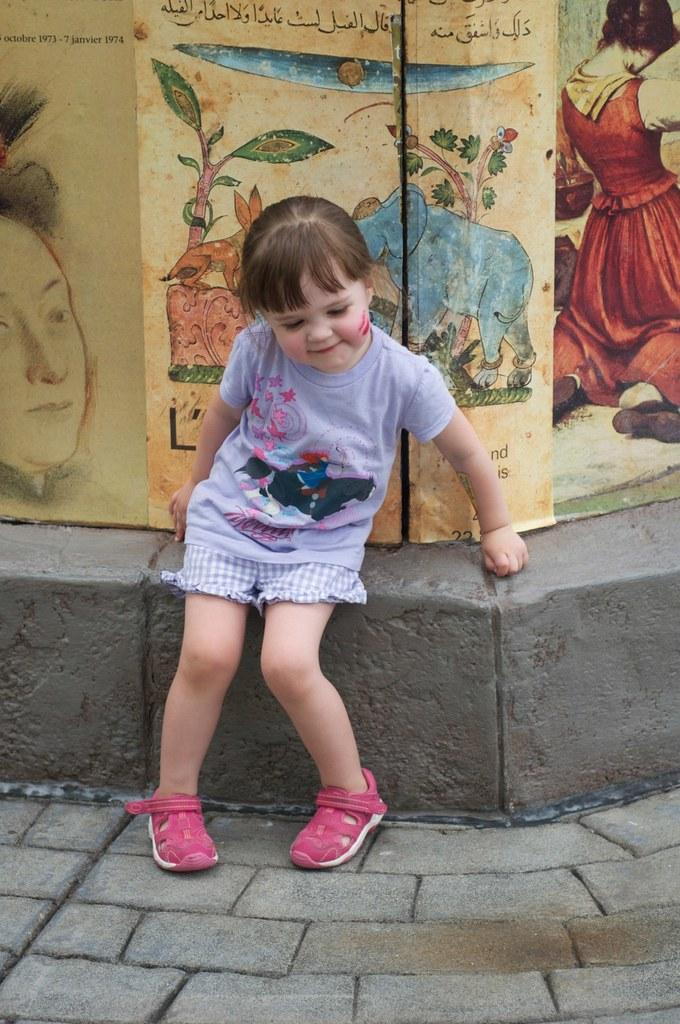Who is the main subject in the image? There is a girl in the image. What is the girl wearing on her upper body? The girl is wearing a T-shirt. What type of shoes is the girl wearing? The girl is wearing pink shoes. What is the surface at the bottom of the image? There is a pavement at the bottom of the image. What can be seen in the background of the image? There is a wall in the background of the image, and there are posters on the wall. What nation does the girl represent in the image? The image does not indicate any specific nation that the girl represents. What impulse caused the girl to wear pink shoes in the image? The image does not provide any information about the girl's motivation for wearing pink shoes. 